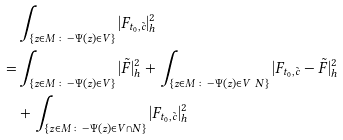Convert formula to latex. <formula><loc_0><loc_0><loc_500><loc_500>& \int _ { \{ z \in M \colon - \Psi ( z ) \in V \} } | F _ { t _ { 0 } , \tilde { c } } | ^ { 2 } _ { h } \\ = & \int _ { \{ z \in M \colon - \Psi ( z ) \in V \} } | \tilde { F } | ^ { 2 } _ { h } + \int _ { \{ z \in M \colon - \Psi ( z ) \in V \ N \} } | F _ { t _ { 0 } , \tilde { c } } - \tilde { F } | ^ { 2 } _ { h } \\ & + \int _ { \{ z \in M \colon - \Psi ( z ) \in V \cap N \} } | F _ { t _ { 0 } , \tilde { c } } | ^ { 2 } _ { h }</formula> 